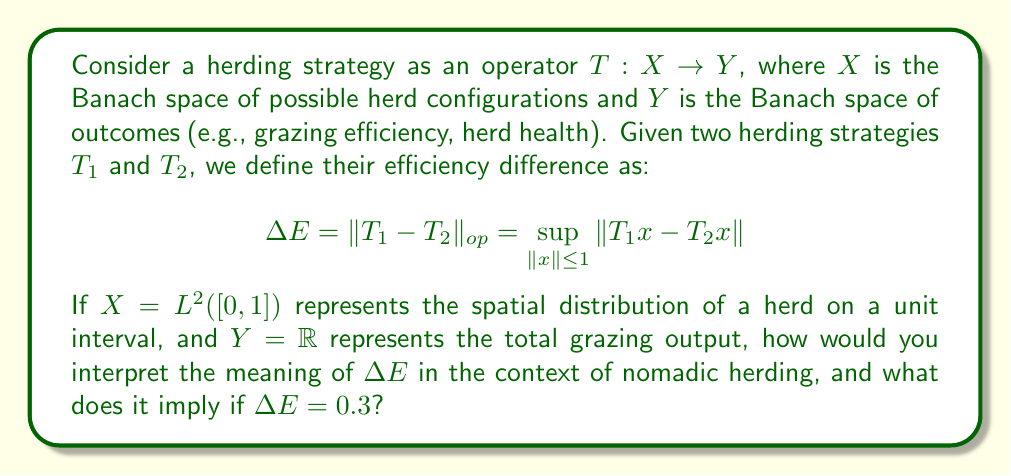Could you help me with this problem? To understand this question in the context of nomadic herding, let's break it down step by step:

1) The Banach spaces:
   - $X = L^2([0,1])$ represents the spatial distribution of a herd on a unit interval. This could be interpreted as the density of animals along a standardized grazing path.
   - $Y = \mathbb{R}$ represents the total grazing output, which could be measured in terms of animal weight gain, milk production, or another relevant metric.

2) The herding strategies $T_1$ and $T_2$ are operators that map the herd distribution to the grazing output. These could represent different methods of moving the herd, managing grazing time, or utilizing different areas of the pasture.

3) The efficiency difference $\Delta E$ is defined as the operator norm of the difference between $T_1$ and $T_2$:

   $$\Delta E = \|T_1 - T_2\|_{op} = \sup_{\|x\| \leq 1} \|T_1x - T_2x\|$$

4) Interpretation of $\Delta E$:
   - $\Delta E$ represents the maximum difference in outcomes between the two strategies for any normalized herd distribution.
   - It quantifies how differently the two strategies perform in the worst-case scenario.
   - A larger $\Delta E$ indicates a greater potential difference between the strategies.

5) In this case, $\Delta E = 0.3$ means:
   - The maximum difference in grazing output between the two strategies is 0.3 units (in whatever units Y is measured).
   - This difference occurs for some herd distribution with an $L^2$ norm of 1 or less.

6) Practical interpretation for nomadic herders:
   - If the grazing output is measured in kilograms of animal weight gain per day, then the two strategies could differ by up to 0.3 kg per day in the most extreme case.
   - This provides a quantitative measure for comparing herding strategies and could inform decisions about which strategy to use in different situations.

7) Limitations of this model:
   - It assumes a linear relationship between herd distribution and output, which may not always be realistic.
   - It doesn't account for temporal variations or external factors like weather, predators, etc.
   - The choice of $L^2$ norm for herd distribution and $\mathbb{R}$ for output is somewhat arbitrary and might not capture all relevant aspects of herding.
Answer: $\Delta E = 0.3$ implies that the maximum difference in grazing output between the two herding strategies is 0.3 units (e.g., 0.3 kg of animal weight gain per day) for any normalized herd distribution. This quantifies the potential impact of choosing one strategy over the other in the most extreme case. 